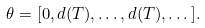<formula> <loc_0><loc_0><loc_500><loc_500>\theta = [ 0 , d ( T ) , \dots , d ( T ) , \dots ] .</formula> 